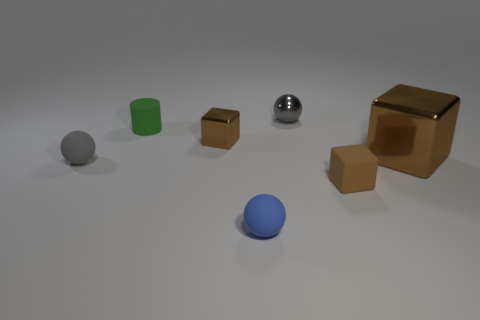What number of gray rubber balls are there?
Keep it short and to the point. 1. There is a rubber thing that is behind the tiny gray matte thing; is its color the same as the metallic thing that is to the left of the small blue sphere?
Offer a very short reply. No. How many things are on the right side of the gray metal object?
Offer a very short reply. 2. What is the material of the big object that is the same color as the matte cube?
Your answer should be compact. Metal. Is there a tiny purple object that has the same shape as the tiny brown matte object?
Your answer should be very brief. No. Does the gray ball in front of the gray metallic object have the same material as the tiny green thing left of the blue ball?
Provide a short and direct response. Yes. There is a rubber ball to the left of the small sphere that is in front of the tiny cube on the right side of the small blue thing; what is its size?
Your answer should be compact. Small. What material is the green thing that is the same size as the blue matte sphere?
Offer a very short reply. Rubber. Are there any brown rubber things that have the same size as the cylinder?
Offer a terse response. Yes. Is the shape of the gray matte object the same as the blue thing?
Make the answer very short. Yes. 